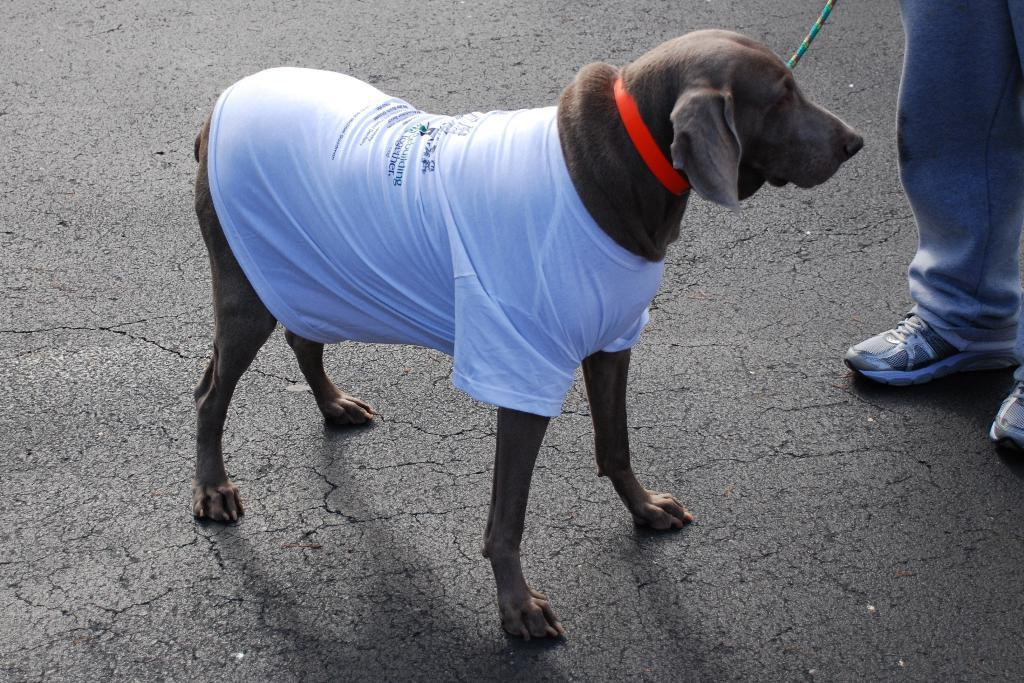What animal can be seen on the road in the image? There is a dog on the road in the image. Can you identify any human presence in the image? Yes, there are legs of a person visible in the image. What type of action are the dog's friends taking in the image? There is no mention of friends or any specific action in the image; it only shows a dog on the road and legs of a person. 